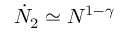<formula> <loc_0><loc_0><loc_500><loc_500>\dot { N } _ { 2 } \simeq N ^ { 1 - \gamma }</formula> 